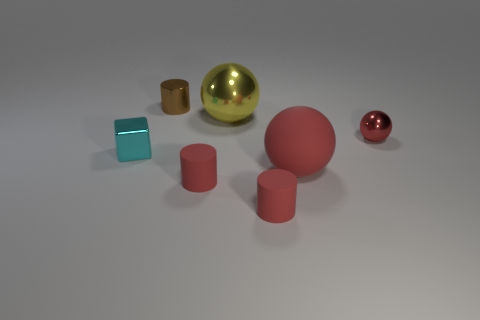There is a sphere in front of the cyan metal cube; what is its size? The sphere in front of the cyan cube is medium-sized in comparison to the surrounding objects, such as the larger red sphere and the smaller red sphere. 